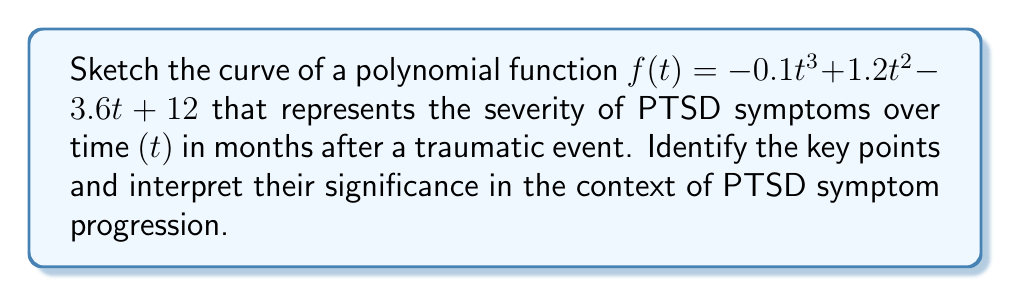Teach me how to tackle this problem. 1. Determine the degree and leading coefficient:
   - Degree: 3 (cubic function)
   - Leading coefficient: -0.1 (negative, so the end behavior will be downward as t → ∞)

2. Find y-intercept:
   $f(0) = -0.1(0)^3 + 1.2(0)^2 - 3.6(0) + 12 = 12$
   Y-intercept: (0, 12)

3. Find x-intercepts by factoring:
   $f(t) = -0.1(t - 2)(t - 4)(t - 10)$
   X-intercepts: (2, 0), (4, 0), (10, 0)

4. Find critical points by solving $f'(t) = 0$:
   $f'(t) = -0.3t^2 + 2.4t - 3.6$
   $-0.3(t^2 - 8t + 12) = 0$
   $-0.3(t - 2)(t - 6) = 0$
   Critical points: t = 2 and t = 6

5. Evaluate $f(6)$ to find the local maximum:
   $f(6) = -0.1(6)^3 + 1.2(6)^2 - 3.6(6) + 12 = 13.6$
   Local maximum: (6, 13.6)

6. Sketch the curve:
[asy]
import graph;
size(200,200);
real f(real x) {return -0.1x^3 + 1.2x^2 - 3.6x + 12;}
draw(graph(f,0,11),blue);
dot((0,12));
dot((2,0));
dot((4,0));
dot((6,13.6));
dot((10,0));
xaxis("t (months)",arrow=Arrow);
yaxis("Symptom Severity",arrow=Arrow);
label("(0,12)",(0,12),NW);
label("(2,0)",(2,0),S);
label("(4,0)",(4,0),S);
label("(6,13.6)",(6,13.6),N);
label("(10,0)",(10,0),S);
[/asy]

Interpretation:
- Y-intercept (0, 12): Initial symptom severity immediately after the traumatic event
- Local maximum (6, 13.6): Peak symptom severity, occurring around 6 months post-event
- X-intercepts (2, 0), (4, 0), (10, 0): Temporary remissions of symptoms
- End behavior: Long-term decrease in symptom severity as time progresses
Answer: Cubic curve with y-intercept (0, 12), local maximum (6, 13.6), and x-intercepts (2, 0), (4, 0), (10, 0), representing PTSD symptom severity over time. 